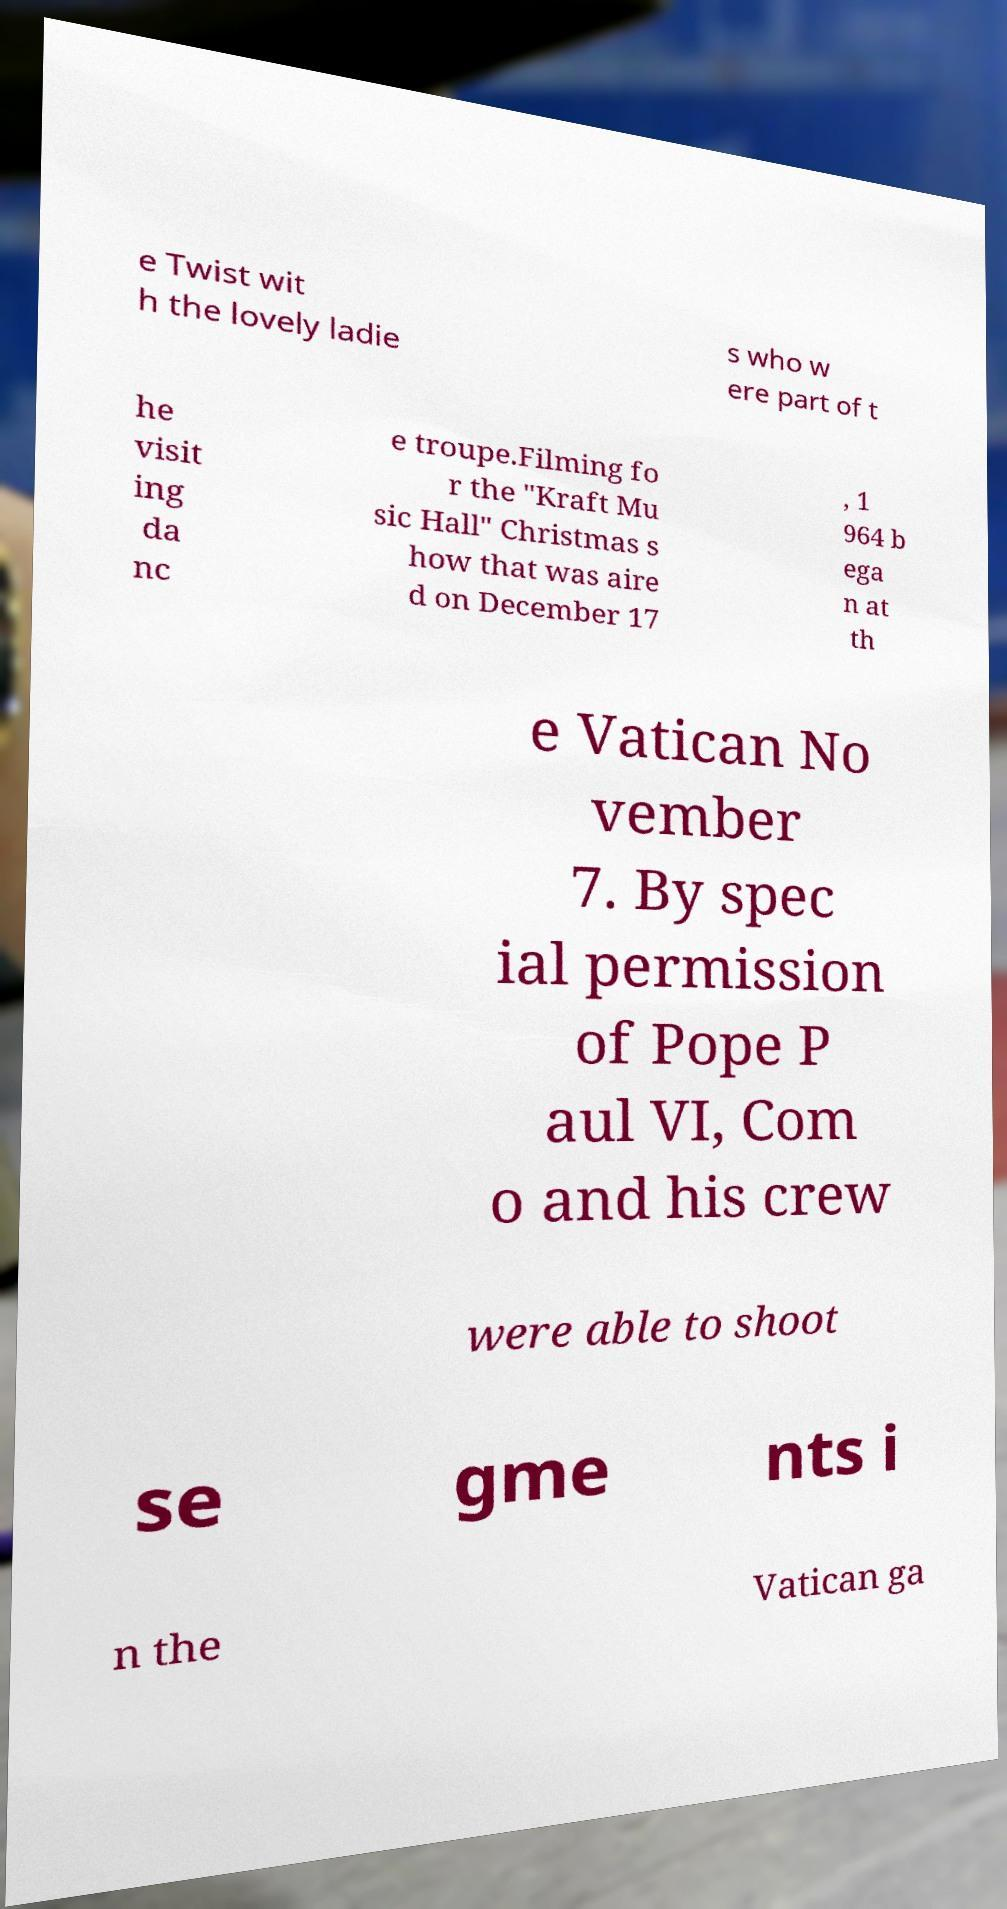Please identify and transcribe the text found in this image. e Twist wit h the lovely ladie s who w ere part of t he visit ing da nc e troupe.Filming fo r the "Kraft Mu sic Hall" Christmas s how that was aire d on December 17 , 1 964 b ega n at th e Vatican No vember 7. By spec ial permission of Pope P aul VI, Com o and his crew were able to shoot se gme nts i n the Vatican ga 